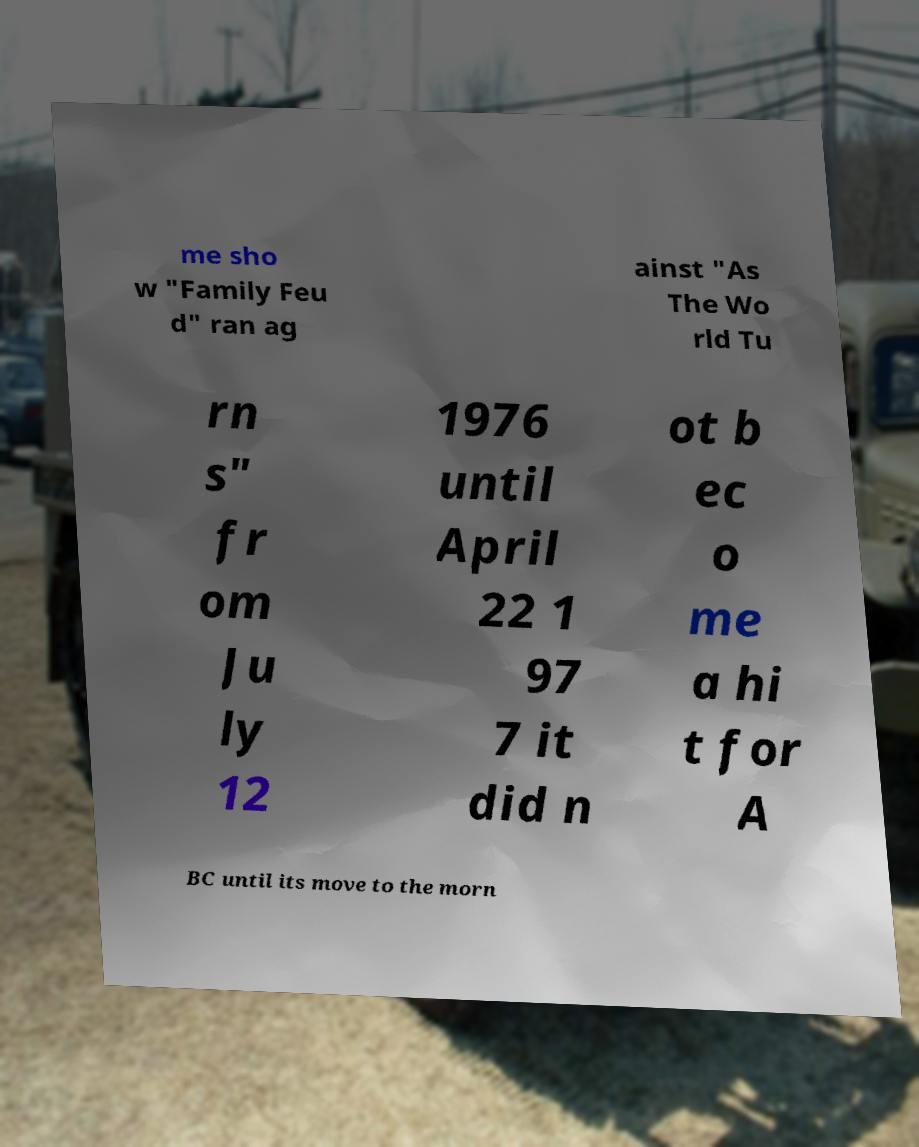Please identify and transcribe the text found in this image. me sho w "Family Feu d" ran ag ainst "As The Wo rld Tu rn s" fr om Ju ly 12 1976 until April 22 1 97 7 it did n ot b ec o me a hi t for A BC until its move to the morn 